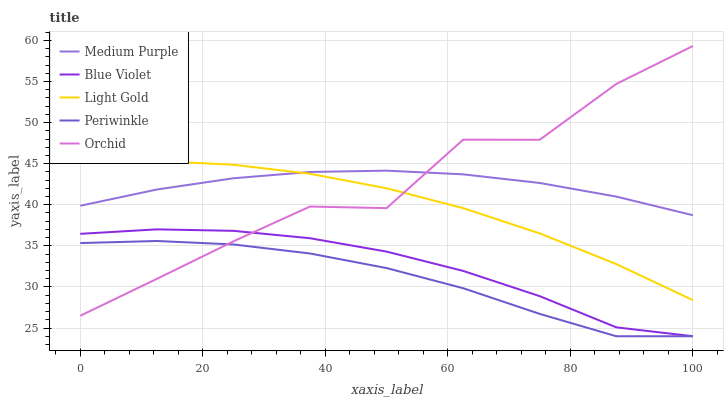Does Periwinkle have the minimum area under the curve?
Answer yes or no. Yes. Does Medium Purple have the maximum area under the curve?
Answer yes or no. Yes. Does Light Gold have the minimum area under the curve?
Answer yes or no. No. Does Light Gold have the maximum area under the curve?
Answer yes or no. No. Is Medium Purple the smoothest?
Answer yes or no. Yes. Is Orchid the roughest?
Answer yes or no. Yes. Is Periwinkle the smoothest?
Answer yes or no. No. Is Periwinkle the roughest?
Answer yes or no. No. Does Periwinkle have the lowest value?
Answer yes or no. Yes. Does Light Gold have the lowest value?
Answer yes or no. No. Does Orchid have the highest value?
Answer yes or no. Yes. Does Light Gold have the highest value?
Answer yes or no. No. Is Blue Violet less than Light Gold?
Answer yes or no. Yes. Is Light Gold greater than Blue Violet?
Answer yes or no. Yes. Does Orchid intersect Blue Violet?
Answer yes or no. Yes. Is Orchid less than Blue Violet?
Answer yes or no. No. Is Orchid greater than Blue Violet?
Answer yes or no. No. Does Blue Violet intersect Light Gold?
Answer yes or no. No. 